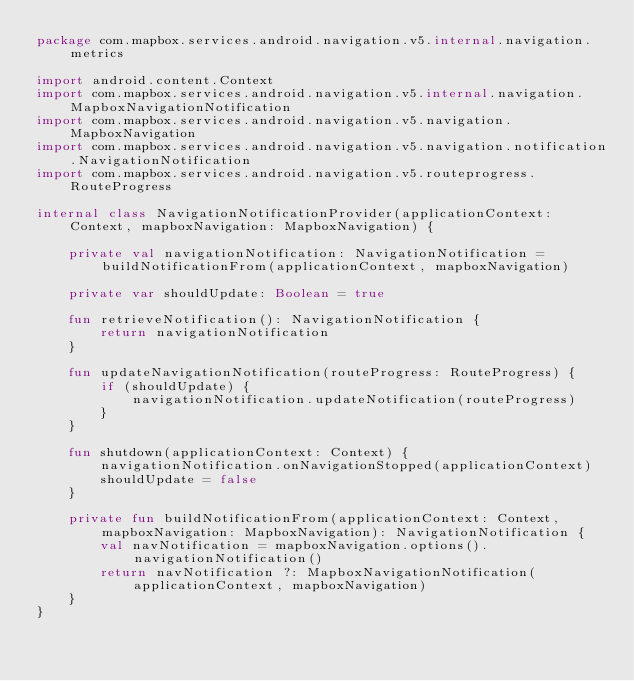<code> <loc_0><loc_0><loc_500><loc_500><_Kotlin_>package com.mapbox.services.android.navigation.v5.internal.navigation.metrics

import android.content.Context
import com.mapbox.services.android.navigation.v5.internal.navigation.MapboxNavigationNotification
import com.mapbox.services.android.navigation.v5.navigation.MapboxNavigation
import com.mapbox.services.android.navigation.v5.navigation.notification.NavigationNotification
import com.mapbox.services.android.navigation.v5.routeprogress.RouteProgress

internal class NavigationNotificationProvider(applicationContext: Context, mapboxNavigation: MapboxNavigation) {

    private val navigationNotification: NavigationNotification = buildNotificationFrom(applicationContext, mapboxNavigation)

    private var shouldUpdate: Boolean = true

    fun retrieveNotification(): NavigationNotification {
        return navigationNotification
    }

    fun updateNavigationNotification(routeProgress: RouteProgress) {
        if (shouldUpdate) {
            navigationNotification.updateNotification(routeProgress)
        }
    }

    fun shutdown(applicationContext: Context) {
        navigationNotification.onNavigationStopped(applicationContext)
        shouldUpdate = false
    }

    private fun buildNotificationFrom(applicationContext: Context, mapboxNavigation: MapboxNavigation): NavigationNotification {
        val navNotification = mapboxNavigation.options().navigationNotification()
        return navNotification ?: MapboxNavigationNotification(applicationContext, mapboxNavigation)
    }
}
</code> 